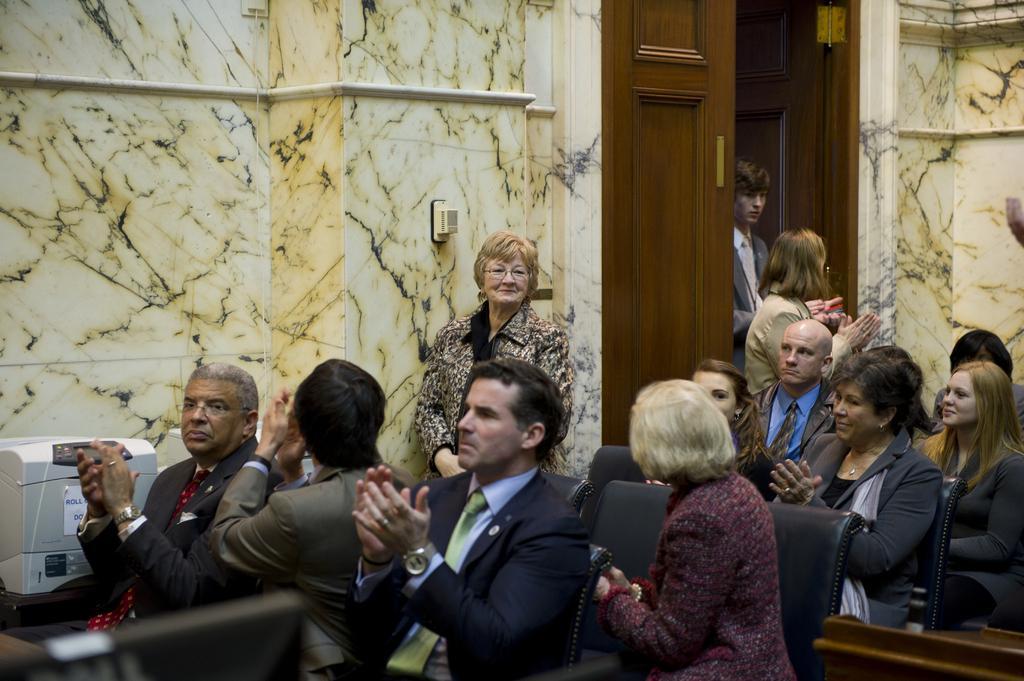Describe this image in one or two sentences. In this image I can see the group of people sitting on the chairs and few people are standing. These people are wearing the different color dresses. To the left I can see the white color electronic gadget. In the back I can see the wall and the door. 